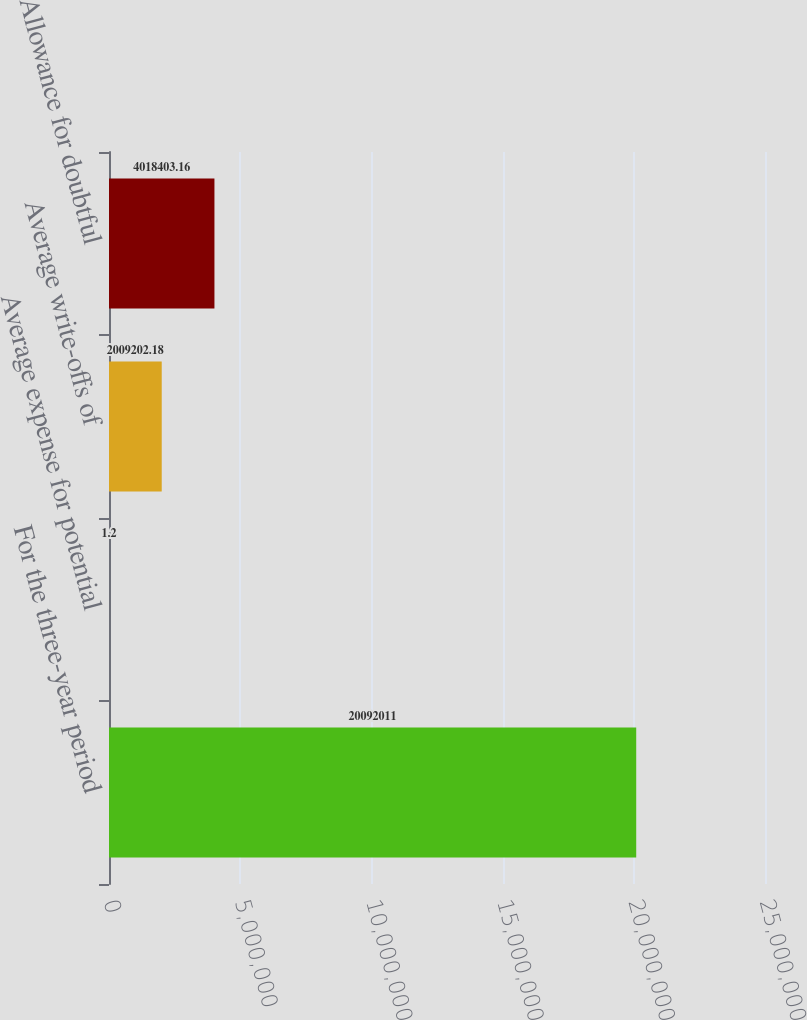Convert chart to OTSL. <chart><loc_0><loc_0><loc_500><loc_500><bar_chart><fcel>For the three-year period<fcel>Average expense for potential<fcel>Average write-offs of<fcel>Allowance for doubtful<nl><fcel>2.0092e+07<fcel>1.2<fcel>2.0092e+06<fcel>4.0184e+06<nl></chart> 